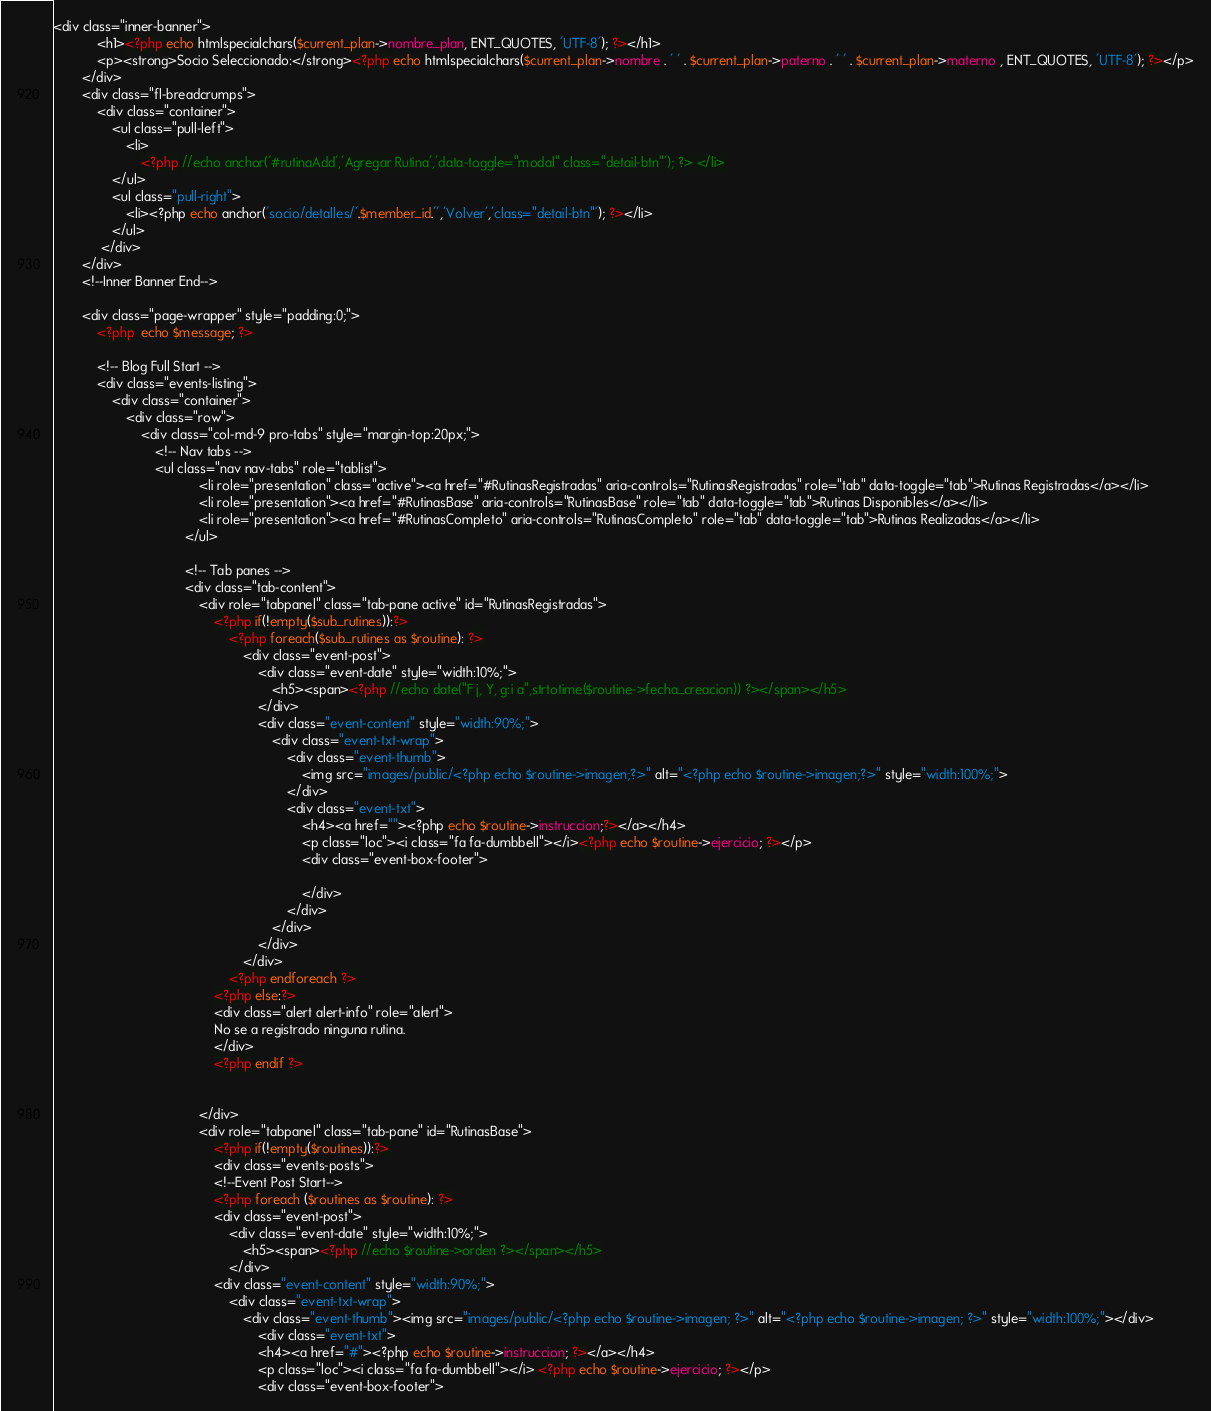Convert code to text. <code><loc_0><loc_0><loc_500><loc_500><_PHP_><div class="inner-banner">
            <h1><?php echo htmlspecialchars($current_plan->nombre_plan, ENT_QUOTES, 'UTF-8'); ?></h1>
            <p><strong>Socio Seleccionado:</strong><?php echo htmlspecialchars($current_plan->nombre . ' ' . $current_plan->paterno . ' ' . $current_plan->materno , ENT_QUOTES, 'UTF-8'); ?></p>
        </div>
        <div class="fl-breadcrumps">
            <div class="container">
                <ul class="pull-left">
                    <li>
                        <?php //echo anchor('#rutinaAdd','Agregar Rutina','data-toggle="modal" class="detail-btn"'); ?> </li>
                </ul>
                <ul class="pull-right">
                    <li><?php echo anchor('socio/detalles/'.$member_id.'','Volver','class="detail-btn"'); ?></li>
                </ul>
             </div>
        </div>
        <!--Inner Banner End-->

        <div class="page-wrapper" style="padding:0;">
            <?php  echo $message; ?>

            <!-- Blog Full Start -->
            <div class="events-listing">
                <div class="container">
                    <div class="row">
                        <div class="col-md-9 pro-tabs" style="margin-top:20px;">
                            <!-- Nav tabs -->
                            <ul class="nav nav-tabs" role="tablist">
                                        <li role="presentation" class="active"><a href="#RutinasRegistradas" aria-controls="RutinasRegistradas" role="tab" data-toggle="tab">Rutinas Registradas</a></li>
                                        <li role="presentation"><a href="#RutinasBase" aria-controls="RutinasBase" role="tab" data-toggle="tab">Rutinas Disponibles</a></li>
                                        <li role="presentation"><a href="#RutinasCompleto" aria-controls="RutinasCompleto" role="tab" data-toggle="tab">Rutinas Realizadas</a></li>
                                    </ul>

                                    <!-- Tab panes -->
                                    <div class="tab-content">
                                        <div role="tabpanel" class="tab-pane active" id="RutinasRegistradas">
                                            <?php if(!empty($sub_rutines)):?>
                                                <?php foreach($sub_rutines as $routine): ?>
                                                    <div class="event-post">
                                                        <div class="event-date" style="width:10%;">
                                                            <h5><span><?php //echo date("F j, Y, g:i a",strtotime($routine->fecha_creacion)) ?></span></h5>
                                                        </div>
                                                        <div class="event-content" style="width:90%;">
                                                            <div class="event-txt-wrap">
                                                                <div class="event-thumb">
                                                                    <img src="images/public/<?php echo $routine->imagen;?>" alt="<?php echo $routine->imagen;?>" style="width:100%;">
                                                                </div>
                                                                <div class="event-txt">
                                                                    <h4><a href=""><?php echo $routine->instruccion;?></a></h4>
                                                                    <p class="loc"><i class="fa fa-dumbbell"></i><?php echo $routine->ejercicio; ?></p>
                                                                    <div class="event-box-footer">

                                                                    </div>
                                                                </div>
                                                            </div>
                                                        </div>
                                                    </div>
                                                <?php endforeach ?>
                                            <?php else:?>
                                            <div class="alert alert-info" role="alert">
                                            No se a registrado ninguna rutina.
                                            </div>
                                            <?php endif ?>
                                            

                                        </div>
                                        <div role="tabpanel" class="tab-pane" id="RutinasBase">
                                            <?php if(!empty($routines)):?>
                                            <div class="events-posts">
                                            <!--Event Post Start-->
                                            <?php foreach ($routines as $routine): ?> 
                                            <div class="event-post">
                                                <div class="event-date" style="width:10%;">
                                                    <h5><span><?php //echo $routine->orden ?></span></h5>
                                                </div>
                                            <div class="event-content" style="width:90%;">
                                                <div class="event-txt-wrap">
                                                    <div class="event-thumb"><img src="images/public/<?php echo $routine->imagen; ?>" alt="<?php echo $routine->imagen; ?>" style="width:100%;"></div>
                                                        <div class="event-txt">
                                                        <h4><a href="#"><?php echo $routine->instruccion; ?></a></h4>
                                                        <p class="loc"><i class="fa fa-dumbbell"></i> <?php echo $routine->ejercicio; ?></p>
                                                        <div class="event-box-footer">  
</code> 